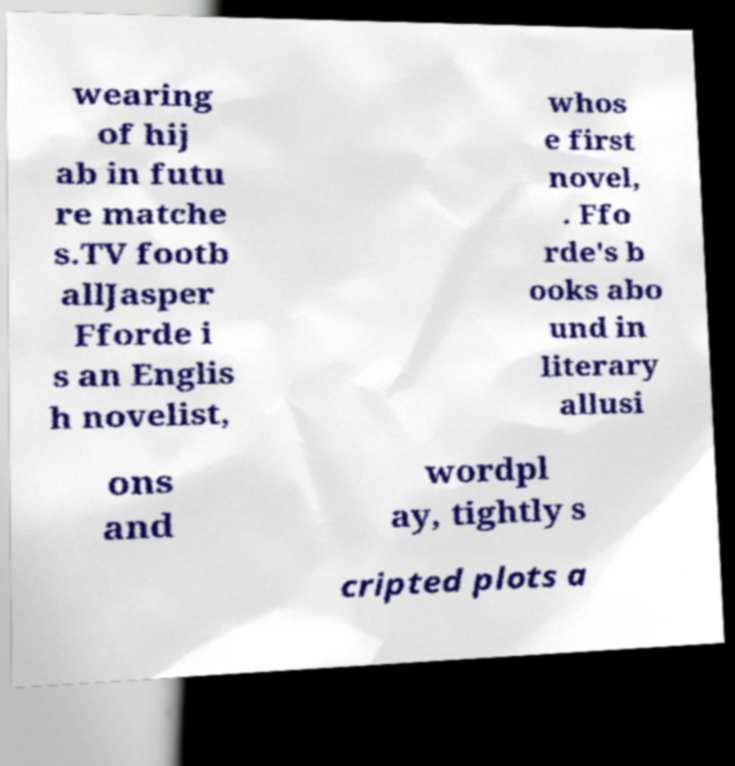Please identify and transcribe the text found in this image. wearing of hij ab in futu re matche s.TV footb allJasper Fforde i s an Englis h novelist, whos e first novel, . Ffo rde's b ooks abo und in literary allusi ons and wordpl ay, tightly s cripted plots a 